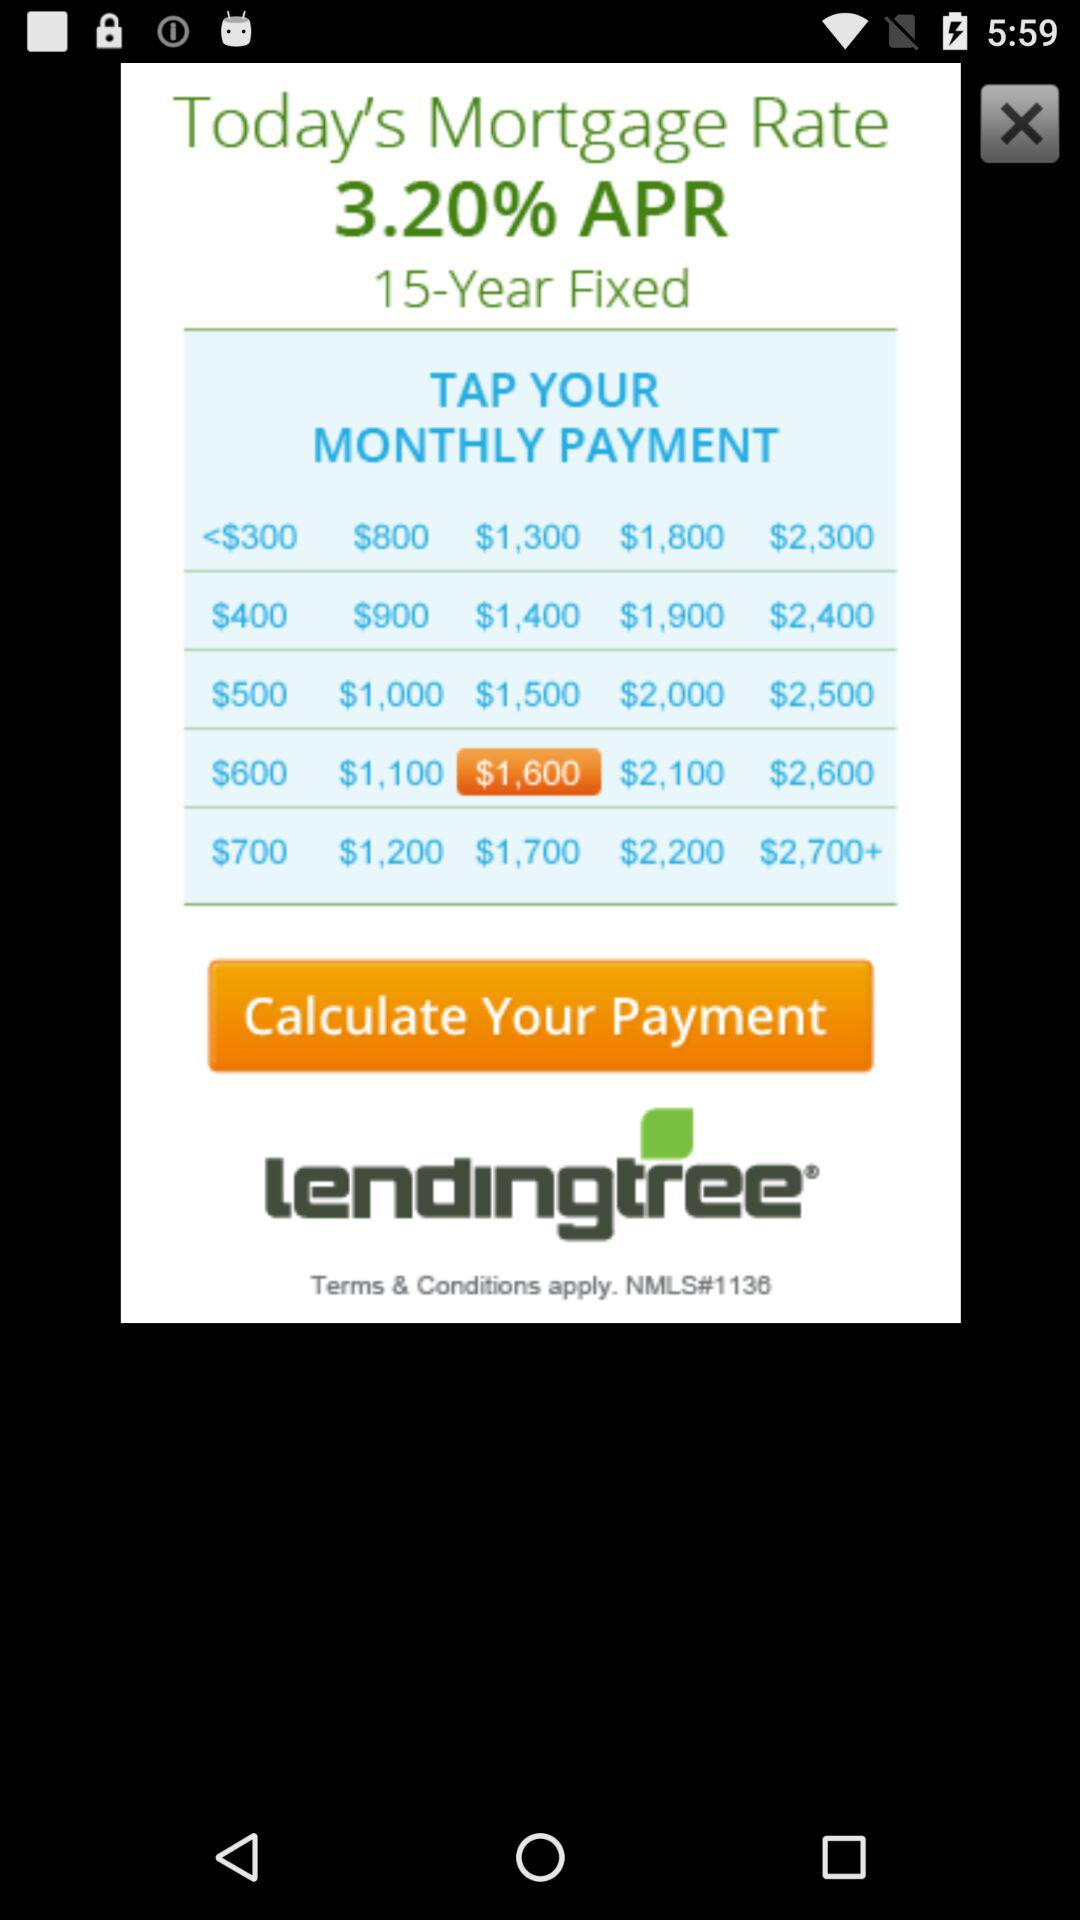For how many years has the mortgage been fixed? The mortgage has been fixed for 15 years. 